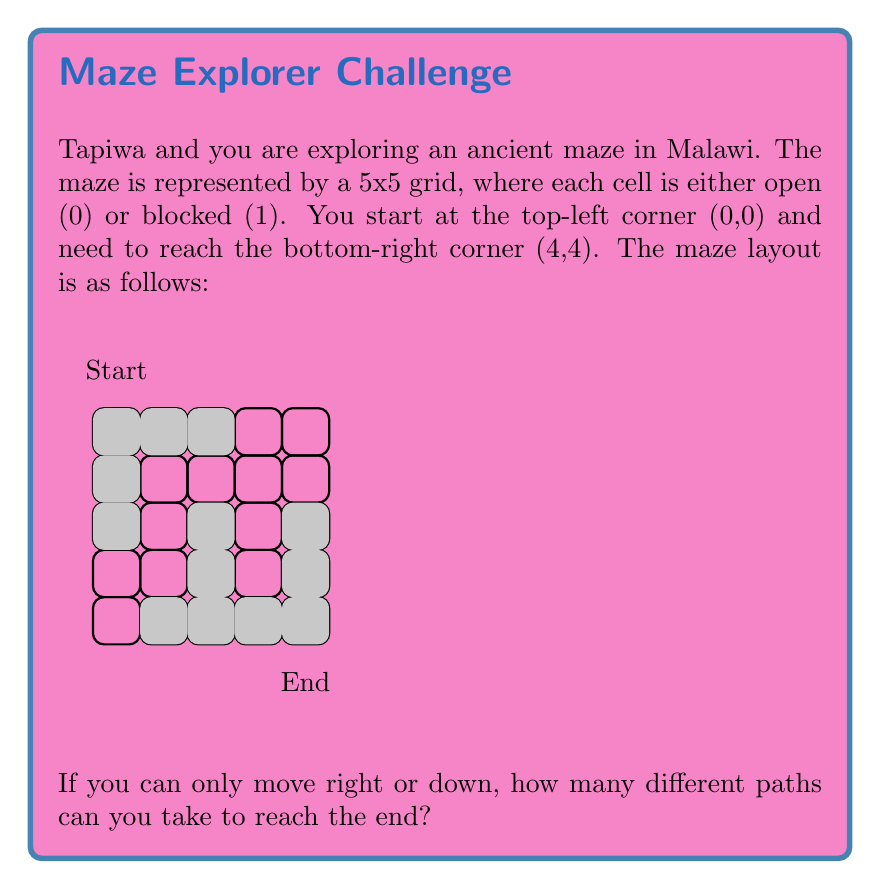Could you help me with this problem? Let's approach this step-by-step using dynamic programming:

1) First, we create a 5x5 grid to store the number of paths to each cell. Let's call this grid $dp$.

2) Initialize the first row and column of $dp$:
   - For the first row, set $dp[0][j] = 1$ if all cells from (0,0) to (0,j) are open.
   - For the first column, set $dp[i][0] = 1$ if all cells from (0,0) to (i,0) are open.

3) For the rest of the cells, we use the formula:
   $dp[i][j] = dp[i-1][j] + dp[i][j-1]$ if the cell is open, and 0 if it's blocked.

4) Fill the $dp$ grid:

   $$
   dp = \begin{bmatrix}
   1 & 1 & 0 & 0 & 0 \\
   0 & 1 & 1 & 1 & 0 \\
   0 & 0 & 0 & 1 & 0 \\
   0 & 0 & 0 & 1 & 1 \\
   0 & 0 & 0 & 0 & 1
   \end{bmatrix}
   $$

5) The value in $dp[4][4]$ gives the total number of paths from start to end.

Therefore, there is only 1 path from start to end in this maze.
Answer: 1 